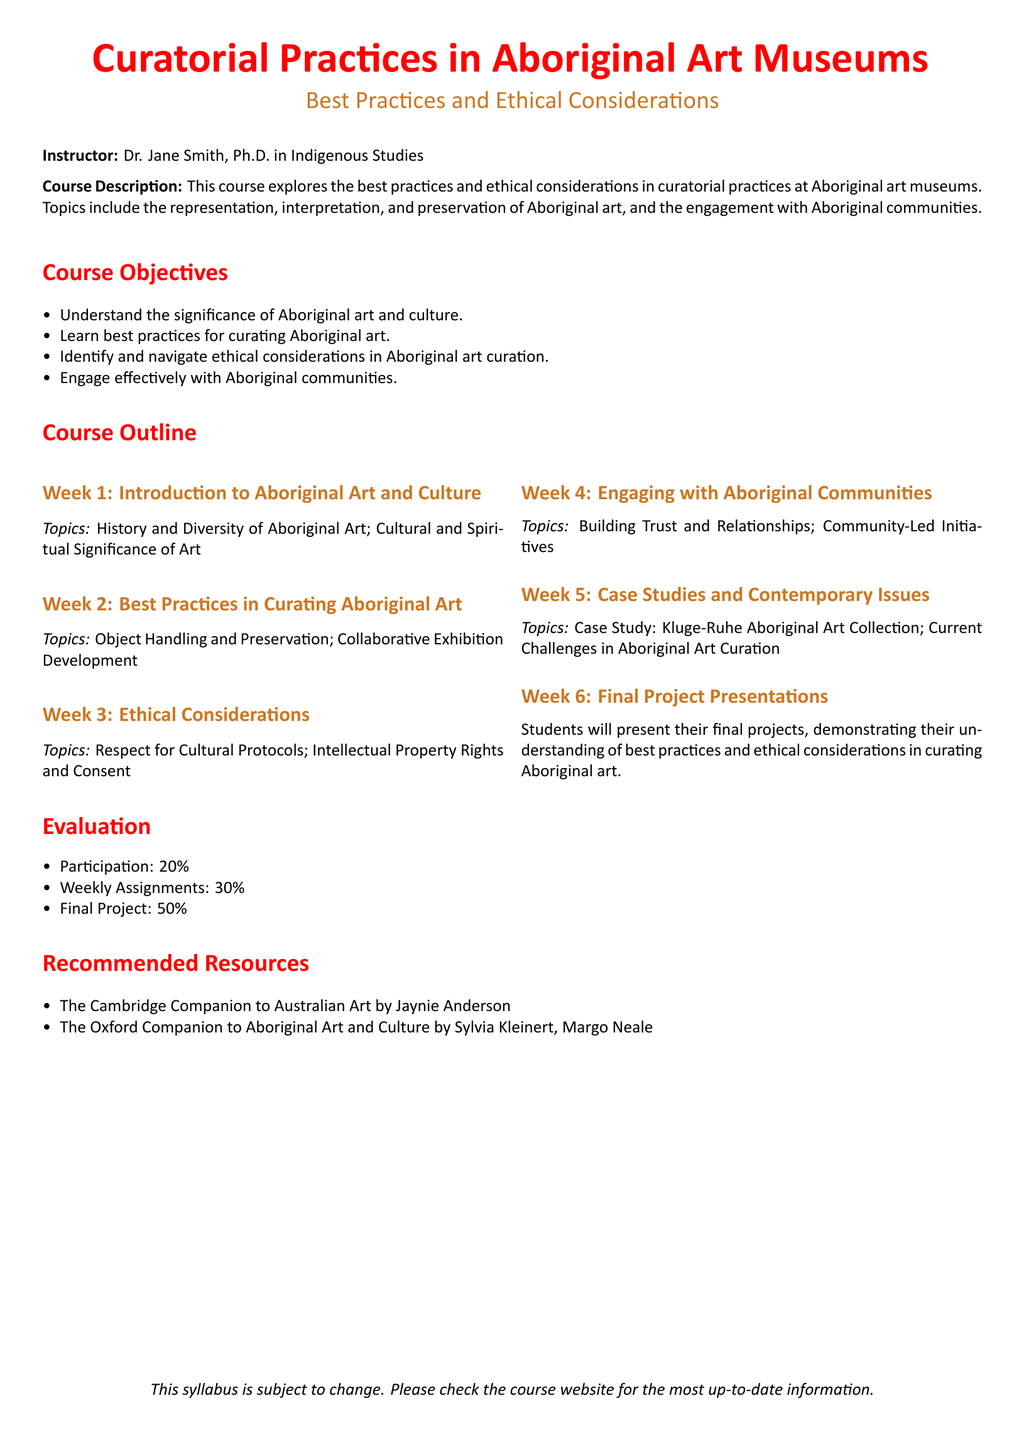What is the name of the instructor? The name of the instructor is provided in the syllabus under the instructor section.
Answer: Dr. Jane Smith What percentage of the final grade is based on participation? The percentage is given in the evaluation section of the syllabus.
Answer: 20% What is the topic of Week 3? The topics for each week are listed in the course outline, and Week 3 is specified under that outline.
Answer: Ethical Considerations Which resource discusses Australian art? The recommended resources include texts, one of which focuses specifically on Australian art.
Answer: The Cambridge Companion to Australian Art How many weeks are covered in the syllabus? The number of weeks is indicated in the course outline section, where each week is listed separately.
Answer: 6 What is the main focus of this course? The main focus can be derived from the course description provided at the beginning of the syllabus.
Answer: Curatorial practices in Aboriginal art museums What type of final assessment is included in the course? The final assessment is mentioned in the evaluation section of the syllabus, detailing what students must do.
Answer: Final Project What building trust with Aboriginal communities focuses on? The topics for Week 4 specify the focus during that week, reflecting on the key theme.
Answer: Building Trust and Relationships 